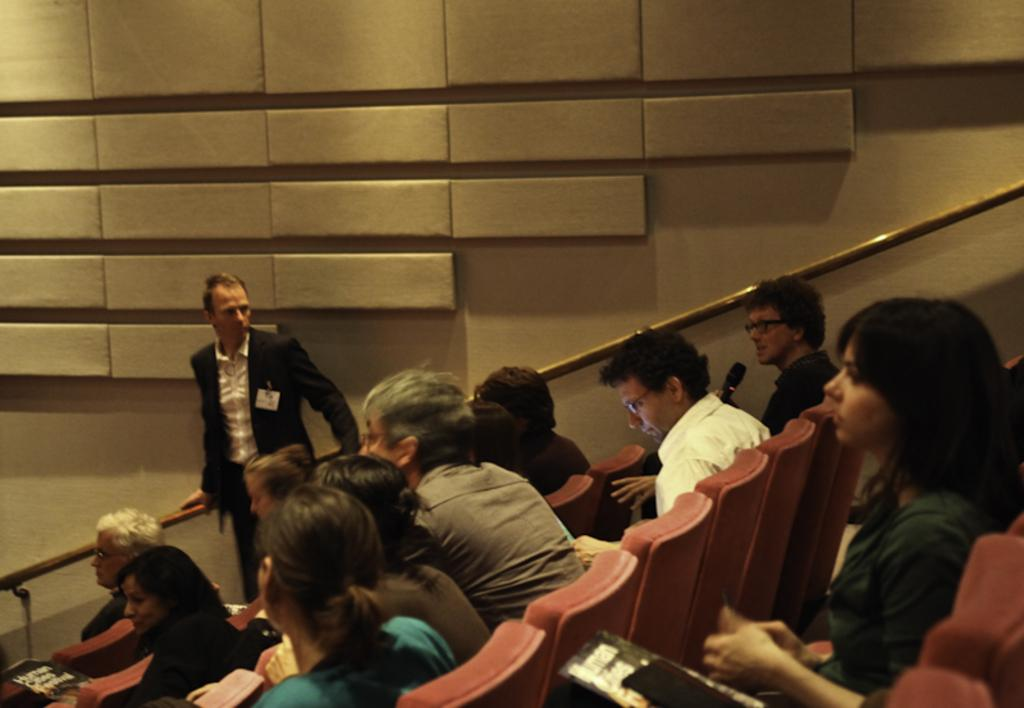What are the people in the image doing? There is a group of people sitting on chairs in the image. Are there any other people in the image besides those sitting? Yes, there is a person standing in the image. What can be seen in the background of the image? There is a staircase holder attached to the wall in the background of the image. What color is the ink on the donkey in the image? There is no donkey or ink present in the image. 